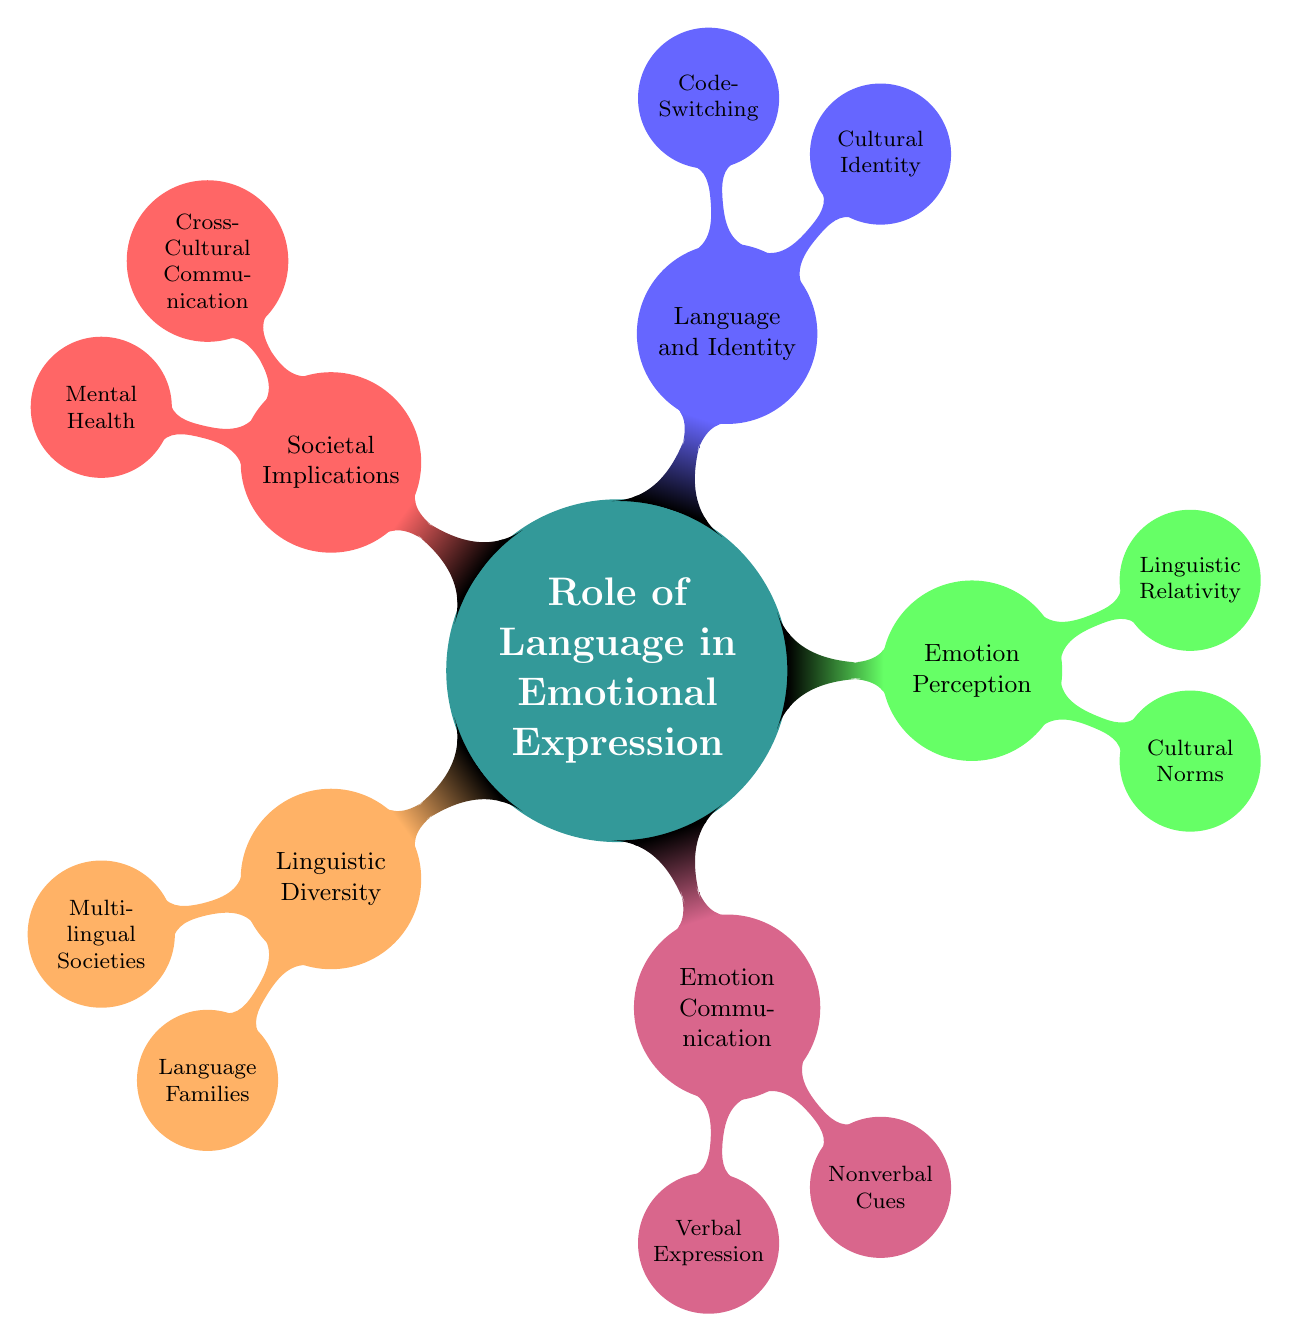What is the main topic of the mind map? The central node of the diagram is labeled "Role of Language in Emotional Expression," indicating that this is the primary subject of the mind map.
Answer: Role of Language in Emotional Expression How many main branches are there in the mind map? The main branches, representing distinct categories of information, include Linguistic Diversity, Emotion Communication, Emotion Perception, Language and Identity, and Societal Implications. There are a total of five main branches.
Answer: 5 What are the two types of expression included under Emotion Communication? The node under Emotion Communication lists two specific types of expression: Verbal Expression and Nonverbal Cues, which directly state the methods of emotional expression.
Answer: Verbal Expression and Nonverbal Cues Which example represents a multilingual society? Under the Linguistic Diversity branch, "Switzerland" is noted as an example of a multilingual society, which indicates a real-world illustration of linguistic diversity.
Answer: Switzerland What hypothesis is associated with Linguistic Relativity? The node under Emotion Perception states "Sapir-Whorf Hypothesis," which is the name of the hypothesis relating to how language influences thought and perception of emotions.
Answer: Sapir-Whorf Hypothesis How does Cultural Norms influence Emotion Perception? The diagram indicates that Cultural Norms are part of the Emotion Perception category, suggesting that different cultural contexts can affect how emotions are perceived and understood, specifically highlighting High-Context vs. Low-Context Cultures.
Answer: It influences how emotions are understood based on cultural contexts Which aspect of Language and Identity is associated with individuals who navigate multiple cultures? The node for Code-Switching under Language and Identity describes individuals who utilize different languages or dialects in different contexts, showcasing the adjustment to cultural identities.
Answer: Code-Switching What societal implication is linked to Language with regards to therapy? The "Mental Health" aspect under Societal Implications highlights the relevance of "Language-Appropriate Therapy," underscoring the importance of language in providing effective mental health services.
Answer: Language-Appropriate Therapy 